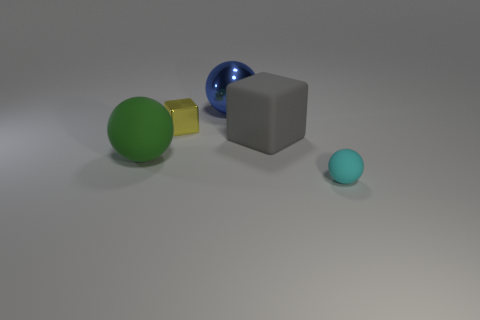Add 1 cyan matte spheres. How many objects exist? 6 Subtract all spheres. How many objects are left? 2 Add 1 small cyan rubber spheres. How many small cyan rubber spheres are left? 2 Add 1 blue metal balls. How many blue metal balls exist? 2 Subtract 0 red cylinders. How many objects are left? 5 Subtract all green things. Subtract all small cyan rubber things. How many objects are left? 3 